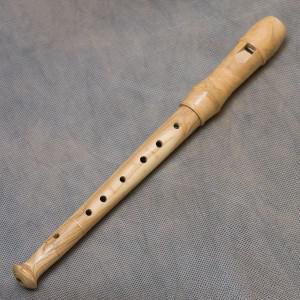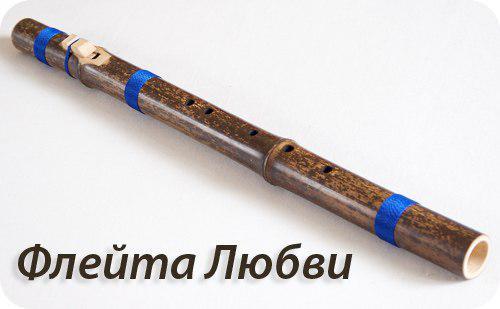The first image is the image on the left, the second image is the image on the right. Considering the images on both sides, is "The instrument in the image on the right has blue bands on it." valid? Answer yes or no. Yes. The first image is the image on the left, the second image is the image on the right. For the images displayed, is the sentence "There is a wood flute in the left image." factually correct? Answer yes or no. Yes. 